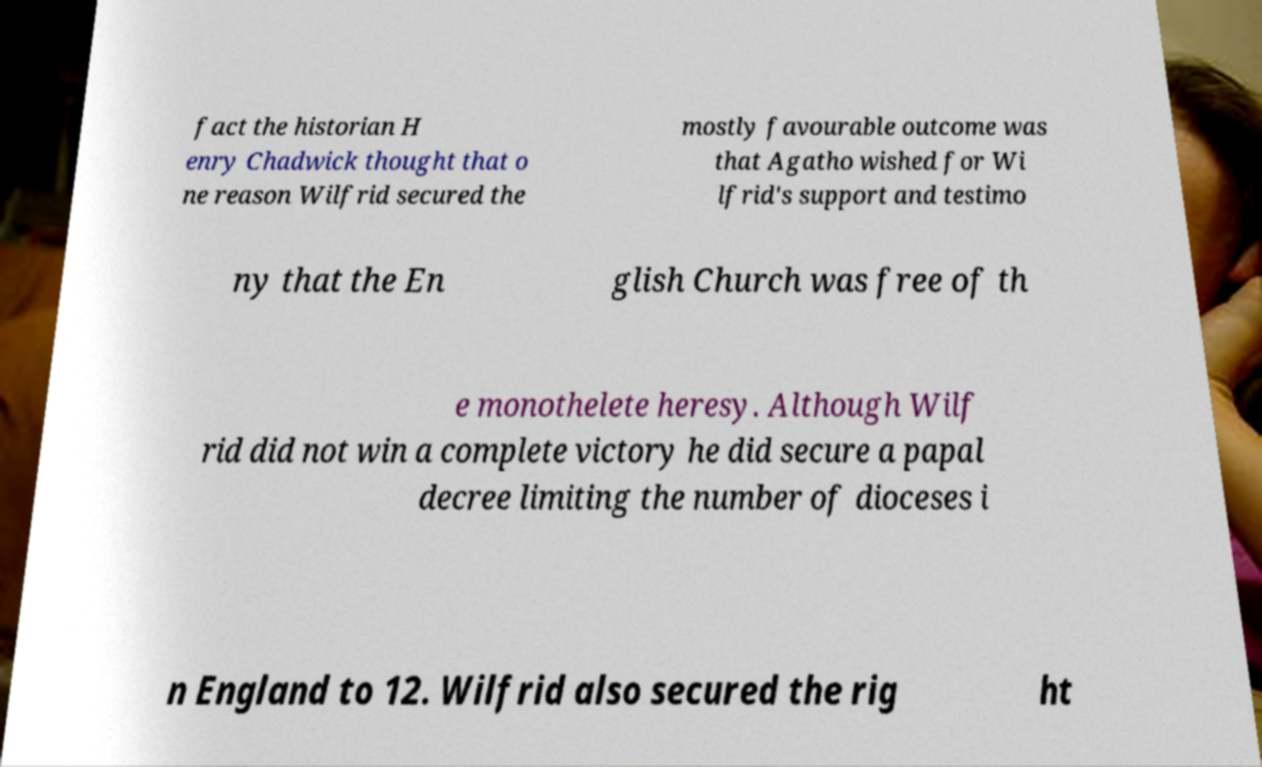Could you extract and type out the text from this image? fact the historian H enry Chadwick thought that o ne reason Wilfrid secured the mostly favourable outcome was that Agatho wished for Wi lfrid's support and testimo ny that the En glish Church was free of th e monothelete heresy. Although Wilf rid did not win a complete victory he did secure a papal decree limiting the number of dioceses i n England to 12. Wilfrid also secured the rig ht 